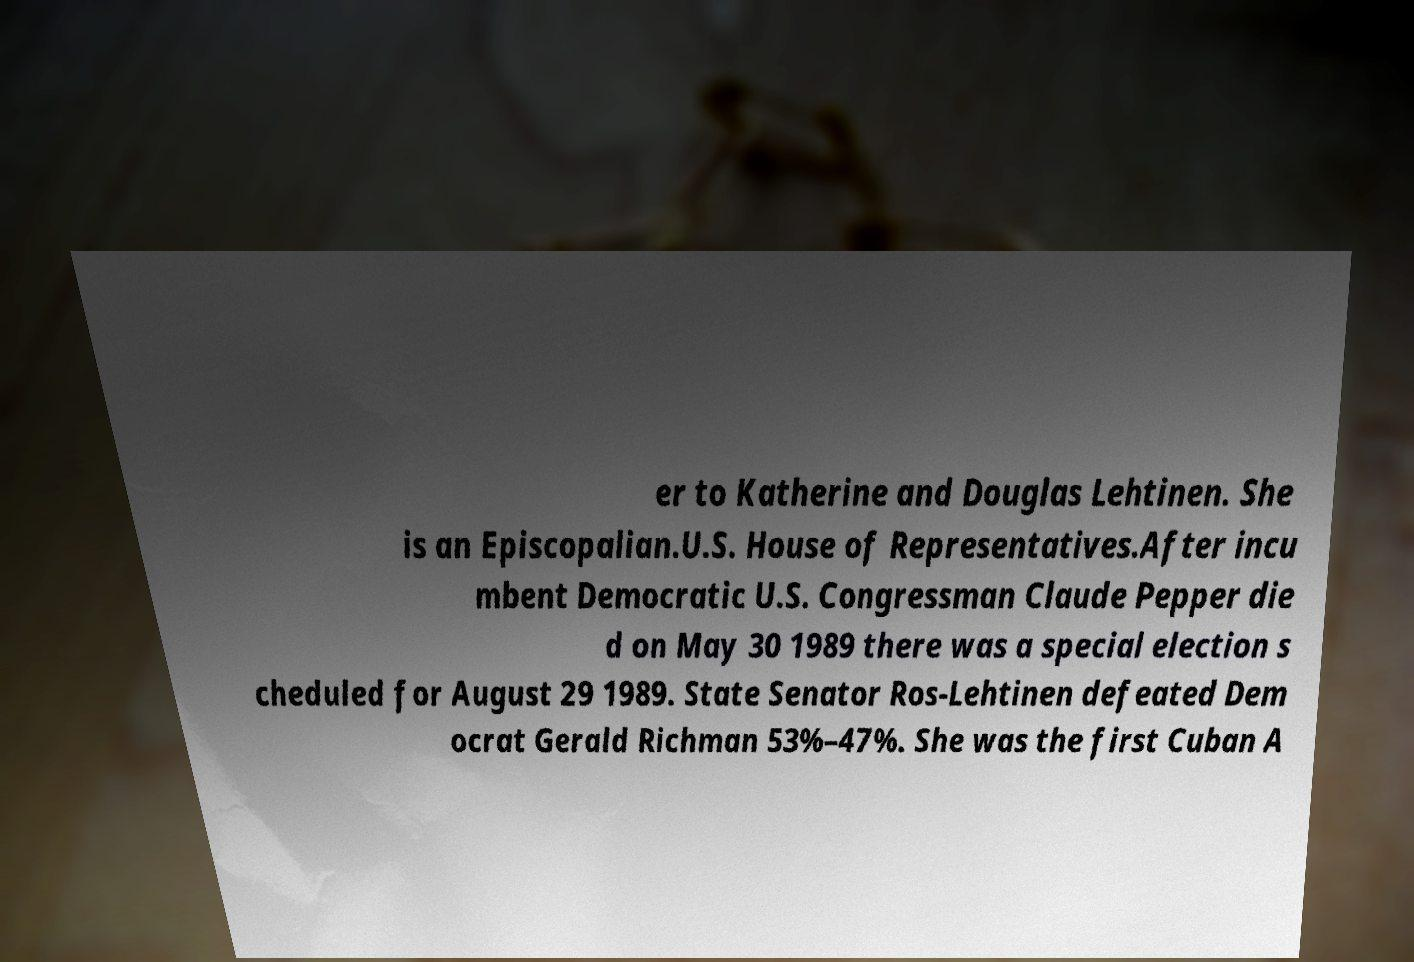For documentation purposes, I need the text within this image transcribed. Could you provide that? er to Katherine and Douglas Lehtinen. She is an Episcopalian.U.S. House of Representatives.After incu mbent Democratic U.S. Congressman Claude Pepper die d on May 30 1989 there was a special election s cheduled for August 29 1989. State Senator Ros-Lehtinen defeated Dem ocrat Gerald Richman 53%–47%. She was the first Cuban A 